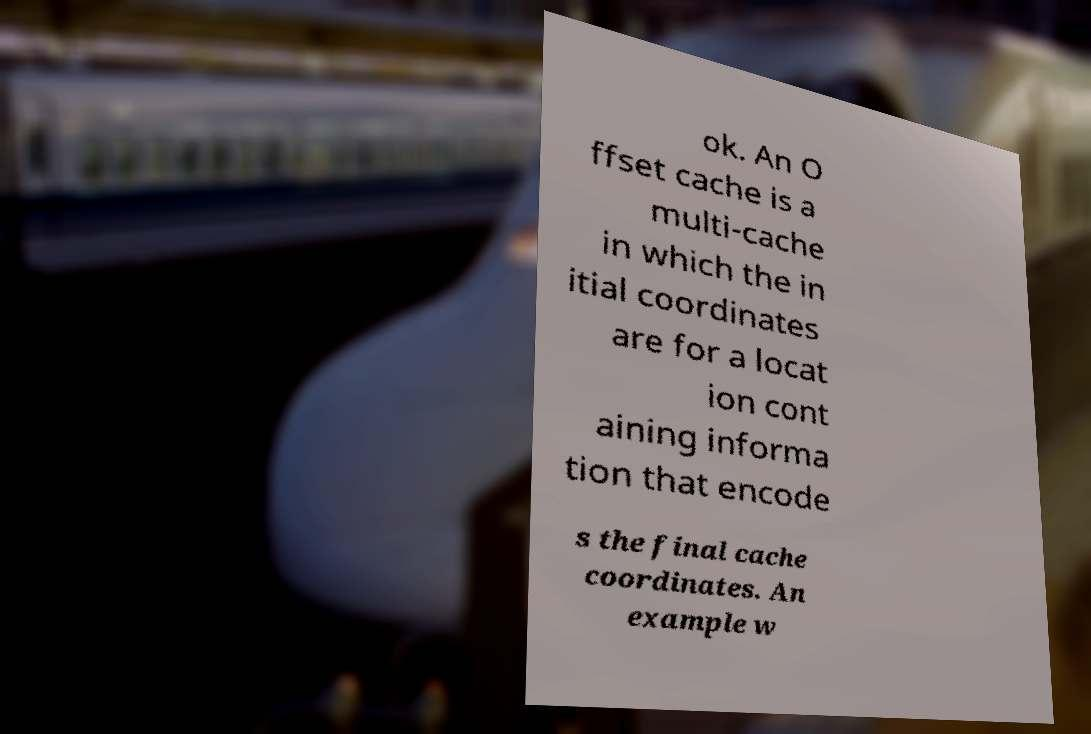Could you assist in decoding the text presented in this image and type it out clearly? ok. An O ffset cache is a multi-cache in which the in itial coordinates are for a locat ion cont aining informa tion that encode s the final cache coordinates. An example w 